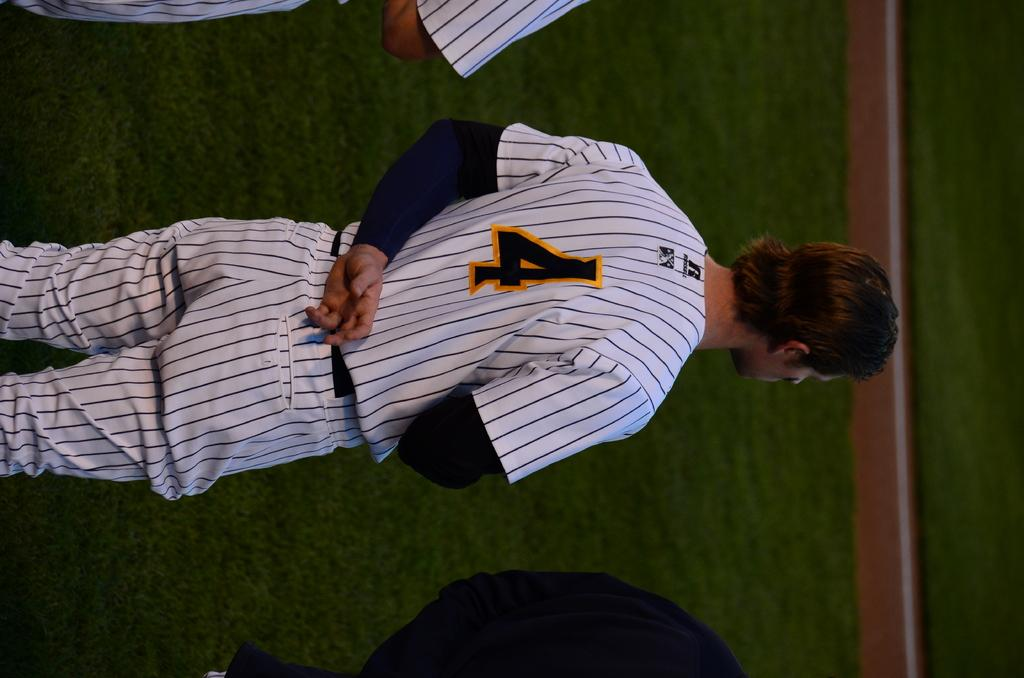<image>
Create a compact narrative representing the image presented. Baseball player #4 stands with one hand behind his back. 